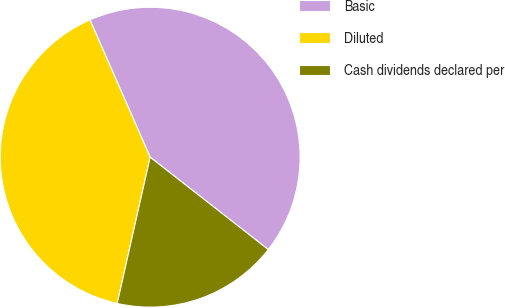<chart> <loc_0><loc_0><loc_500><loc_500><pie_chart><fcel>Basic<fcel>Diluted<fcel>Cash dividends declared per<nl><fcel>42.14%<fcel>39.9%<fcel>17.96%<nl></chart> 